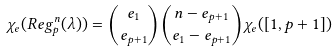Convert formula to latex. <formula><loc_0><loc_0><loc_500><loc_500>\chi _ { e } ( R e g ^ { n } _ { p } ( \lambda ) ) = { e _ { 1 } \choose e _ { p + 1 } } { n - e _ { p + 1 } \choose e _ { 1 } - e _ { p + 1 } } \chi _ { e } ( [ 1 , p + 1 ] )</formula> 